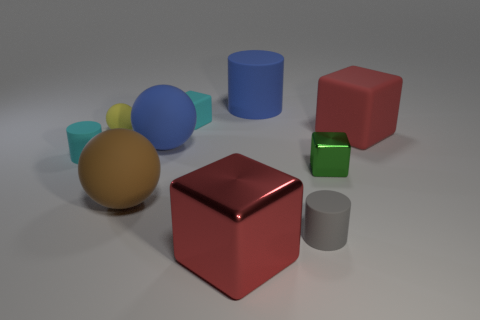Subtract all blocks. How many objects are left? 6 Add 8 tiny gray matte things. How many tiny gray matte things are left? 9 Add 3 small yellow shiny things. How many small yellow shiny things exist? 3 Subtract 1 blue cylinders. How many objects are left? 9 Subtract all cyan matte cylinders. Subtract all big brown things. How many objects are left? 8 